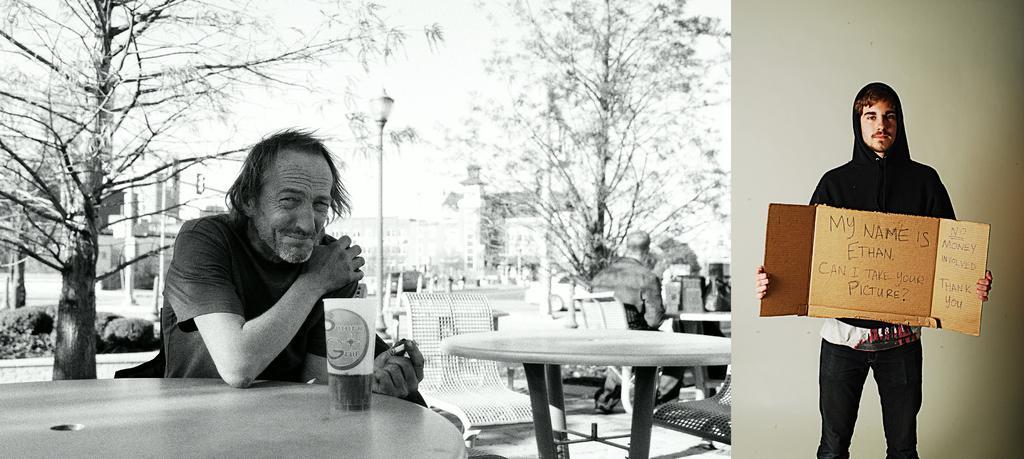Could you give a brief overview of what you see in this image? on the right side of this image I can see a man standing. He's wearing black jacket and holding one sheet in his hands. On the left bottom of this image I can see a table and a glass on it. one person is sitting on the chair. He is having cigarette in his hand. In the background I can see buildings and one street light and trees as well. On the left side I can see some plants. In the centre of the image I can see another person sitting. 